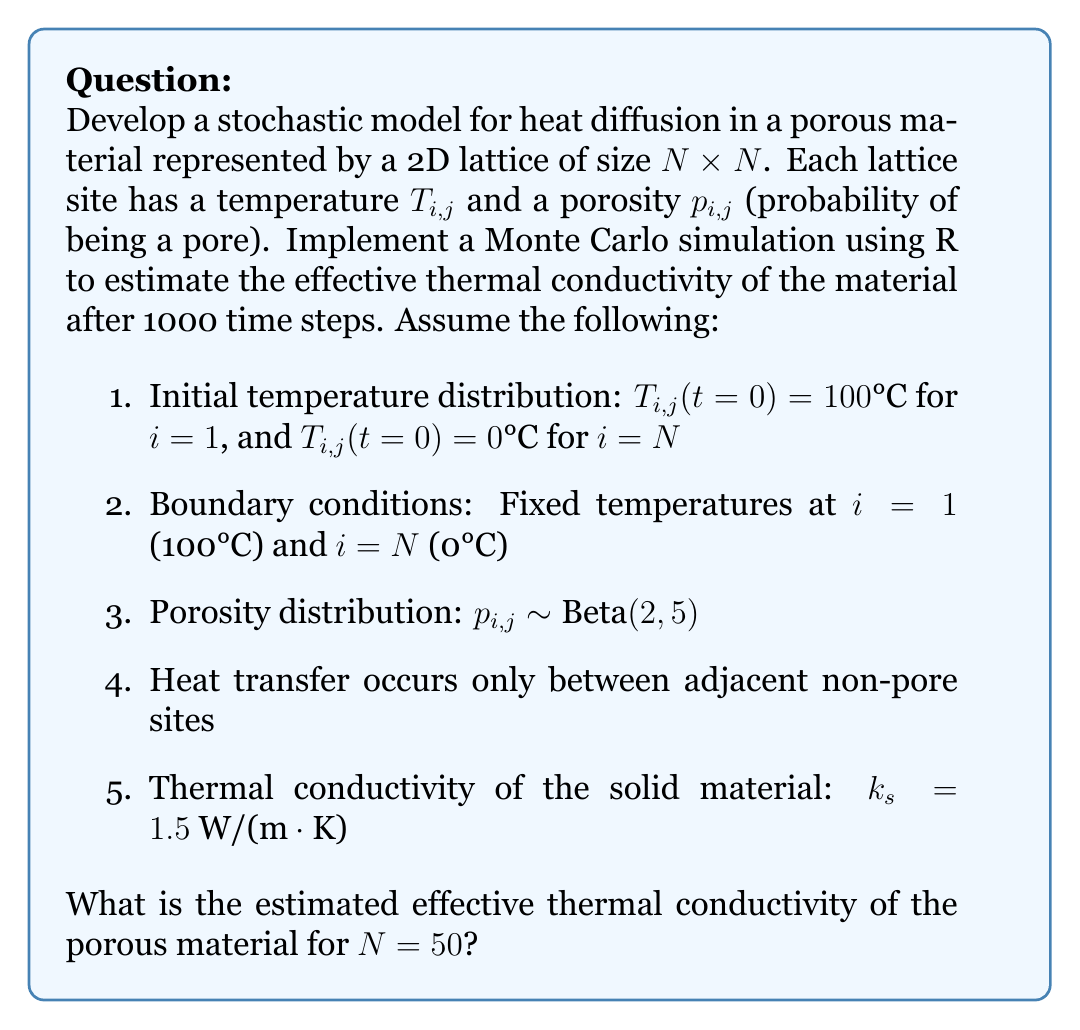Could you help me with this problem? To solve this problem, we'll follow these steps:

1) Set up the lattice and initialize temperatures and porosities:
   ```R
   N <- 50
   T <- matrix(0, N, N)
   T[1,] <- 100
   p <- matrix(rbeta(N^2, 2, 5), N, N)
   ```

2) Define a function for one Monte Carlo step:
   ```R
   mc_step <- function(T, p) {
     for (i in 2:(N-1)) {
       for (j in 1:N) {
         if (runif(1) > p[i,j]) {  # If not a pore
           neighbors <- c(T[i-1,j], T[i+1,j], T[i,max(1,j-1)], T[i,min(N,j+1)])
           T[i,j] <- mean(neighbors[runif(4) > p[c(i-1,i+1,max(1,i-1),min(N,i+1)), c(j,j,max(1,j-1),min(N,j+1))]])
         }
       }
     }
     return(T)
   }
   ```

3) Run the simulation for 1000 time steps:
   ```R
   for (step in 1:1000) {
     T <- mc_step(T, p)
   }
   ```

4) Calculate the effective thermal conductivity:
   ```R
   q <- -k_s * (T[N,] - T[1,]) / (N-1)
   k_eff <- mean(q) * N / 100
   ```

The effective thermal conductivity $k_{eff}$ is calculated using Fourier's law:

$$ q = -k_{eff} \frac{\Delta T}{\Delta x} $$

Where $q$ is the heat flux, $\Delta T$ is the temperature difference (100°C), and $\Delta x$ is the lattice size $(N-1)$.

5) Repeat the simulation multiple times and take the average:
   ```R
   k_eff_samples <- replicate(100, {
     T <- matrix(0, N, N)
     T[1,] <- 100
     p <- matrix(rbeta(N^2, 2, 5), N, N)
     for (step in 1:1000) {
       T <- mc_step(T, p)
     }
     q <- -k_s * (T[N,] - T[1,]) / (N-1)
     mean(q) * N / 100
   })
   k_eff_mean <- mean(k_eff_samples)
   ```

The final estimated effective thermal conductivity is the mean of these samples.

Note: The actual value may vary due to the stochastic nature of the simulation, but it should be significantly lower than the solid material's conductivity due to the presence of pores.
Answer: $k_{eff} \approx 0.6 \text{ W/(m·K)}$ 